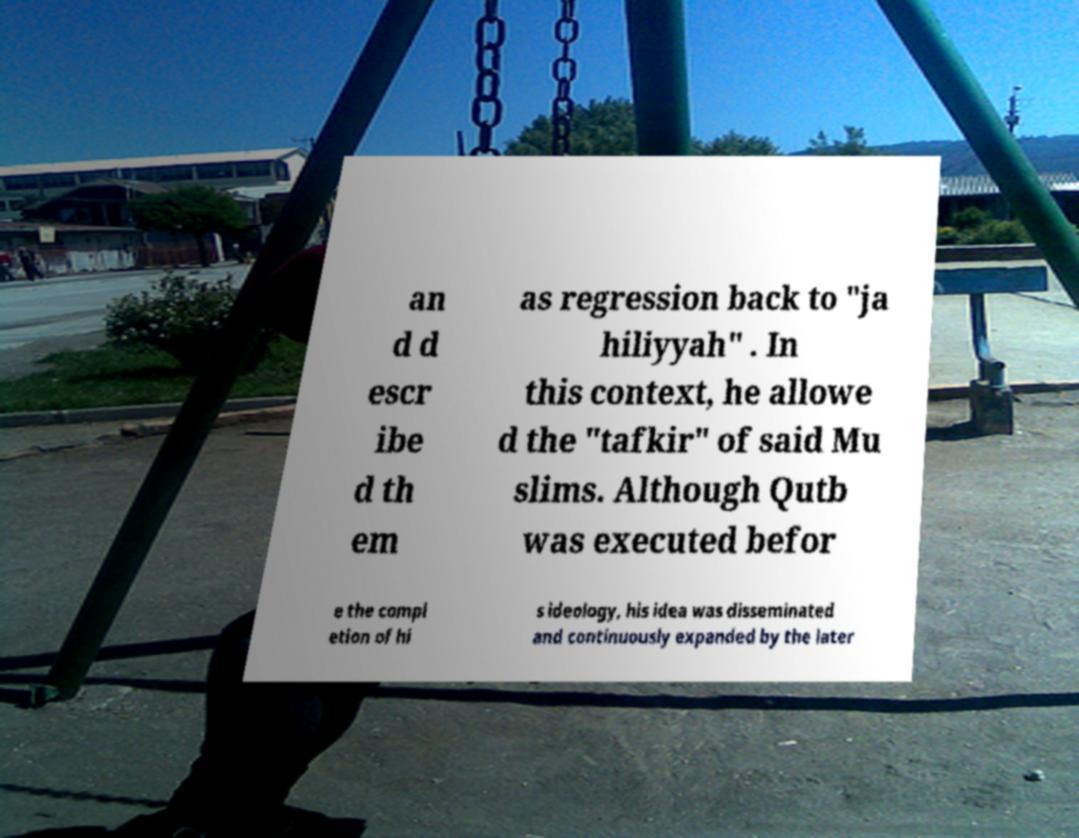Please identify and transcribe the text found in this image. an d d escr ibe d th em as regression back to "ja hiliyyah" . In this context, he allowe d the "tafkir" of said Mu slims. Although Qutb was executed befor e the compl etion of hi s ideology, his idea was disseminated and continuously expanded by the later 